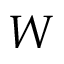Convert formula to latex. <formula><loc_0><loc_0><loc_500><loc_500>W</formula> 